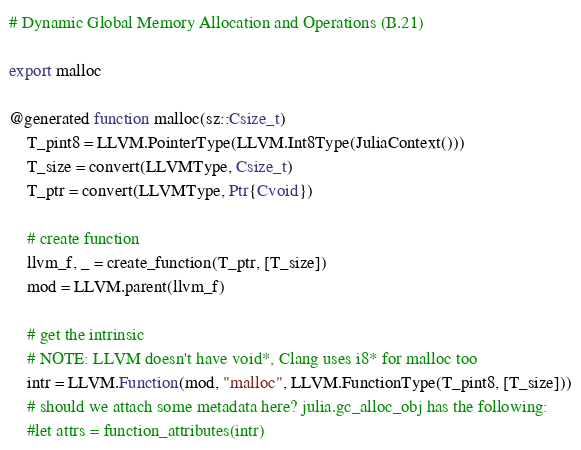Convert code to text. <code><loc_0><loc_0><loc_500><loc_500><_Julia_># Dynamic Global Memory Allocation and Operations (B.21)

export malloc

@generated function malloc(sz::Csize_t)
    T_pint8 = LLVM.PointerType(LLVM.Int8Type(JuliaContext()))
    T_size = convert(LLVMType, Csize_t)
    T_ptr = convert(LLVMType, Ptr{Cvoid})

    # create function
    llvm_f, _ = create_function(T_ptr, [T_size])
    mod = LLVM.parent(llvm_f)

    # get the intrinsic
    # NOTE: LLVM doesn't have void*, Clang uses i8* for malloc too
    intr = LLVM.Function(mod, "malloc", LLVM.FunctionType(T_pint8, [T_size]))
    # should we attach some metadata here? julia.gc_alloc_obj has the following:
    #let attrs = function_attributes(intr)</code> 